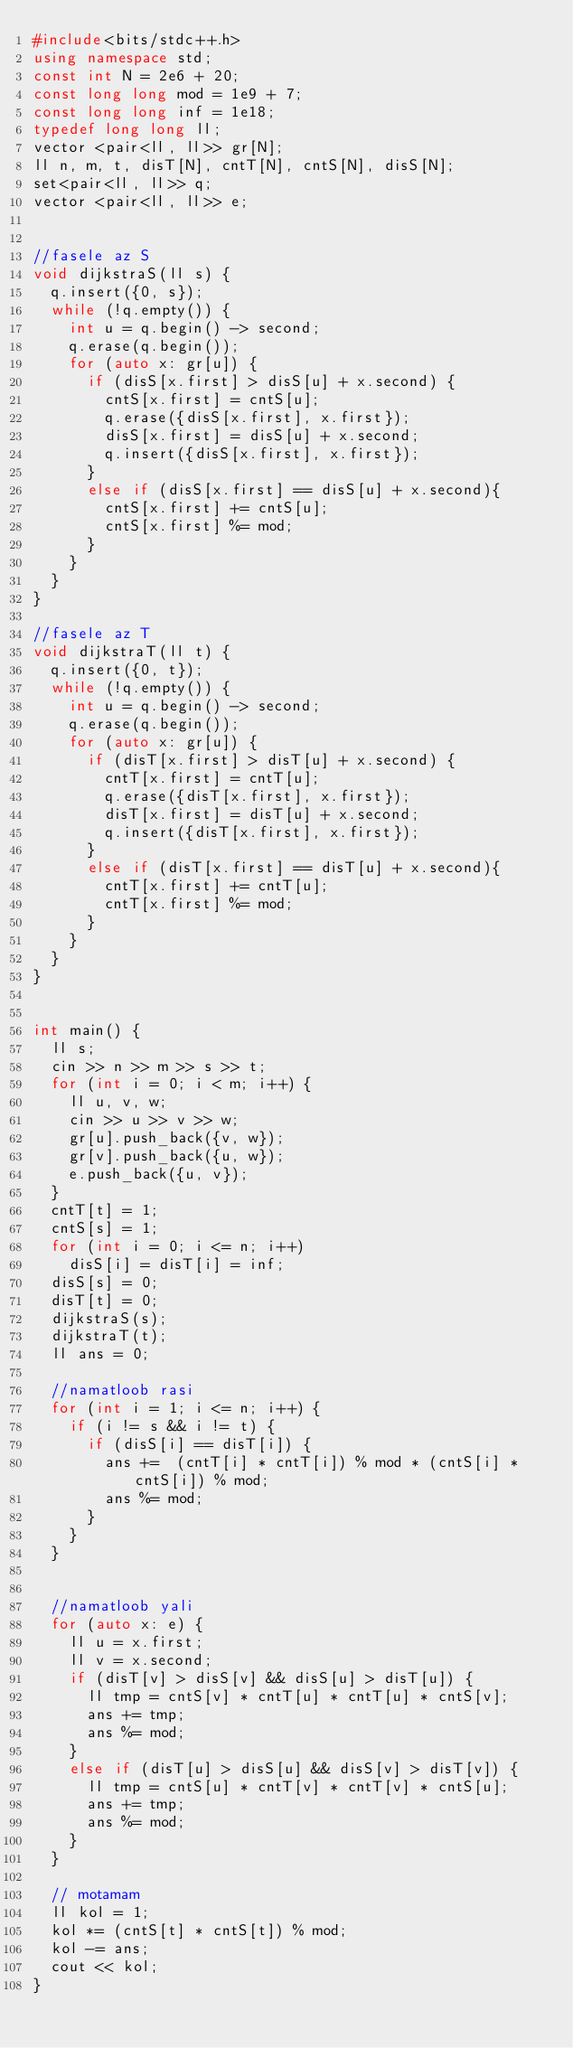<code> <loc_0><loc_0><loc_500><loc_500><_C++_>#include<bits/stdc++.h>
using namespace std;
const int N = 2e6 + 20;
const long long mod = 1e9 + 7;
const long long inf = 1e18;
typedef long long ll;
vector <pair<ll, ll>> gr[N];
ll n, m, t, disT[N], cntT[N], cntS[N], disS[N];
set<pair<ll, ll>> q;
vector <pair<ll, ll>> e;


//fasele az S
void dijkstraS(ll s) {
	q.insert({0, s});
	while (!q.empty()) {
		int u = q.begin() -> second;
		q.erase(q.begin());
		for (auto x: gr[u]) {
			if (disS[x.first] > disS[u] + x.second) {
				cntS[x.first] = cntS[u];
				q.erase({disS[x.first], x.first});
				disS[x.first] = disS[u] + x.second;
				q.insert({disS[x.first], x.first});
			}
			else if (disS[x.first] == disS[u] + x.second){
				cntS[x.first] += cntS[u];
				cntS[x.first] %= mod;
			}	
		}
	}	
}

//fasele az T
void dijkstraT(ll t) {
	q.insert({0, t});
	while (!q.empty()) {
		int u = q.begin() -> second;
		q.erase(q.begin());
		for (auto x: gr[u]) {
			if (disT[x.first] > disT[u] + x.second) {
				cntT[x.first] = cntT[u];
				q.erase({disT[x.first], x.first});
				disT[x.first] = disT[u] + x.second;
				q.insert({disT[x.first], x.first});
			}
			else if (disT[x.first] == disT[u] + x.second){
				cntT[x.first] += cntT[u];
				cntT[x.first] %= mod;
			}	
		}
	}	
}


int main() {
	ll s;
	cin >> n >> m >> s >> t;
	for (int i = 0; i < m; i++) {
		ll u, v, w;
		cin >> u >> v >> w;
		gr[u].push_back({v, w});
		gr[v].push_back({u, w});
		e.push_back({u, v});
	}	
	cntT[t] = 1;
	cntS[s] = 1;
	for (int i = 0; i <= n; i++)
		disS[i] = disT[i] = inf;
	disS[s] = 0;
	disT[t] = 0;
	dijkstraS(s);
	dijkstraT(t);
	ll ans = 0;
	
	//namatloob rasi
	for (int i = 1; i <= n; i++) {
		if (i != s && i != t) {
			if (disS[i] == disT[i]) {
				ans += 	(cntT[i] * cntT[i]) % mod * (cntS[i] * cntS[i]) % mod;
				ans %= mod;
			}
		}
	}
	
	
	//namatloob yali
	for (auto x: e) {
		ll u = x.first;
		ll v = x.second;
		if (disT[v] > disS[v] && disS[u] > disT[u]) {
			ll tmp = cntS[v] * cntT[u] * cntT[u] * cntS[v];
			ans += tmp;
			ans %= mod; 
		}
		else if (disT[u] > disS[u] && disS[v] > disT[v]) {
			ll tmp = cntS[u] * cntT[v] * cntT[v] * cntS[u];
			ans += tmp;
			ans %= mod; 
		}
	}
	
	// motamam
	ll kol = 1;
	kol *= (cntS[t] * cntS[t]) % mod;
	kol -= ans;
	cout << kol;
}</code> 